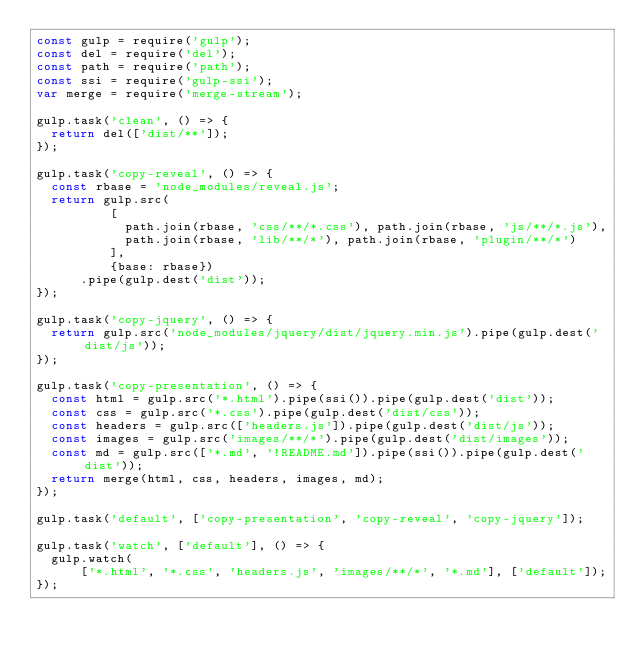<code> <loc_0><loc_0><loc_500><loc_500><_JavaScript_>const gulp = require('gulp');
const del = require('del');
const path = require('path');
const ssi = require('gulp-ssi');
var merge = require('merge-stream');

gulp.task('clean', () => {
  return del(['dist/**']);
});

gulp.task('copy-reveal', () => {
  const rbase = 'node_modules/reveal.js';
  return gulp.src(
          [
            path.join(rbase, 'css/**/*.css'), path.join(rbase, 'js/**/*.js'),
            path.join(rbase, 'lib/**/*'), path.join(rbase, 'plugin/**/*')
          ],
          {base: rbase})
      .pipe(gulp.dest('dist'));
});

gulp.task('copy-jquery', () => {
  return gulp.src('node_modules/jquery/dist/jquery.min.js').pipe(gulp.dest('dist/js'));
});

gulp.task('copy-presentation', () => {
  const html = gulp.src('*.html').pipe(ssi()).pipe(gulp.dest('dist'));
  const css = gulp.src('*.css').pipe(gulp.dest('dist/css'));
  const headers = gulp.src(['headers.js']).pipe(gulp.dest('dist/js'));
  const images = gulp.src('images/**/*').pipe(gulp.dest('dist/images'));
  const md = gulp.src(['*.md', '!README.md']).pipe(ssi()).pipe(gulp.dest('dist'));
  return merge(html, css, headers, images, md);
});

gulp.task('default', ['copy-presentation', 'copy-reveal', 'copy-jquery']);

gulp.task('watch', ['default'], () => {
  gulp.watch(
      ['*.html', '*.css', 'headers.js', 'images/**/*', '*.md'], ['default']);
});
</code> 